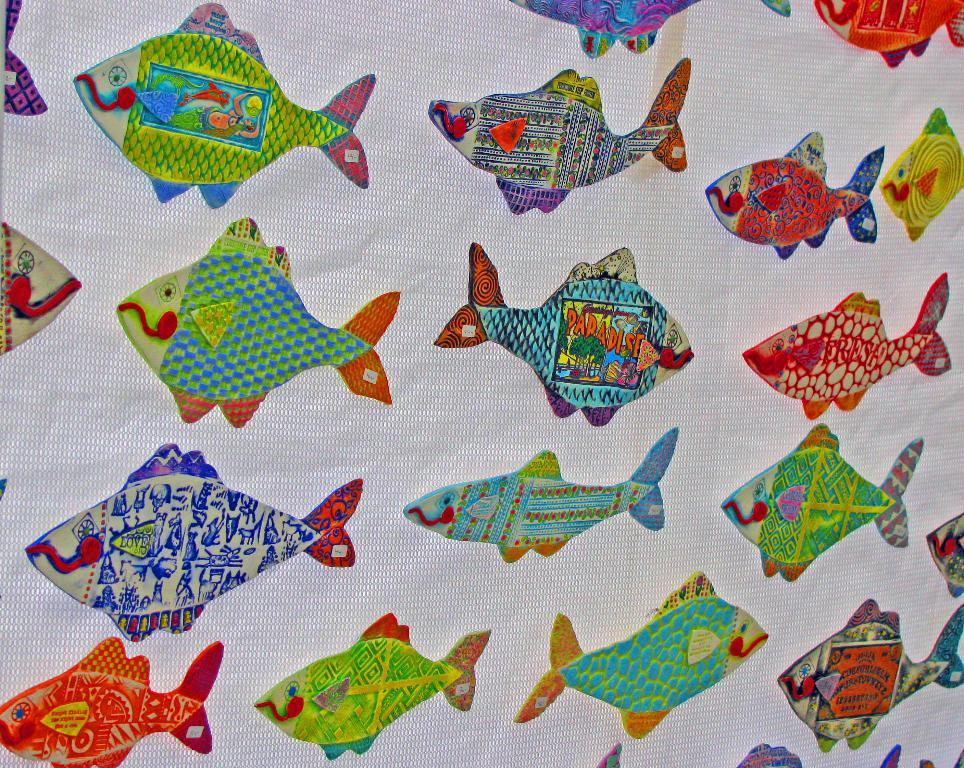What type of artwork is featured in the image? There is a thread craft in the image. What is the subject matter of the thread craft? The thread craft depicts fishes. What color is the cloth on which the thread craft is made? The cloth on which the thread craft is made is white. Where is the mailbox located in the image? There is no mailbox present in the image. How many bikes are visible in the image? There are no bikes visible in the image. 